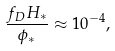<formula> <loc_0><loc_0><loc_500><loc_500>\frac { f _ { D } H _ { * } } { \phi _ { * } } \approx 1 0 ^ { - 4 } ,</formula> 